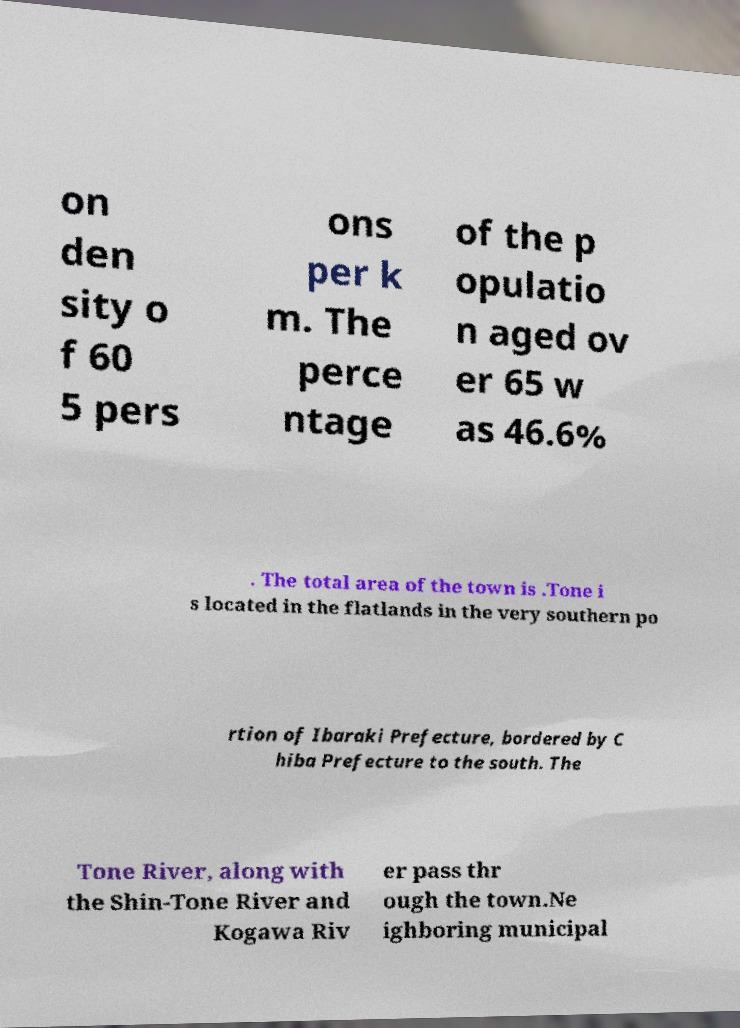What messages or text are displayed in this image? I need them in a readable, typed format. on den sity o f 60 5 pers ons per k m. The perce ntage of the p opulatio n aged ov er 65 w as 46.6% . The total area of the town is .Tone i s located in the flatlands in the very southern po rtion of Ibaraki Prefecture, bordered by C hiba Prefecture to the south. The Tone River, along with the Shin-Tone River and Kogawa Riv er pass thr ough the town.Ne ighboring municipal 